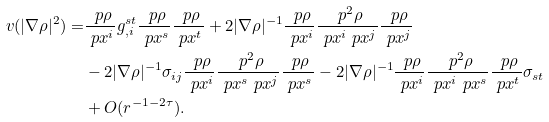<formula> <loc_0><loc_0><loc_500><loc_500>v ( | \nabla \rho | ^ { 2 } ) = & \frac { \ p \rho } { \ p x ^ { i } } g ^ { s t } _ { , i } \frac { \ p \rho } { \ p x ^ { s } } \frac { \ p \rho } { \ p x ^ { t } } + 2 | \nabla \rho | ^ { - 1 } \frac { \ p \rho } { \ p x ^ { i } } \frac { \ p ^ { 2 } \rho } { \ p x ^ { i } \ p x ^ { j } } \frac { \ p \rho } { \ p x ^ { j } } \\ & - 2 | \nabla \rho | ^ { - 1 } \sigma _ { i j } \frac { \ p \rho } { \ p x ^ { i } } \frac { \ p ^ { 2 } \rho } { \ p x ^ { s } \ p x ^ { j } } \frac { \ p \rho } { \ p x ^ { s } } - 2 | \nabla \rho | ^ { - 1 } \frac { \ p \rho } { \ p x ^ { i } } \frac { \ p ^ { 2 } \rho } { \ p x ^ { i } \ p x ^ { s } } \frac { \ p \rho } { \ p x ^ { t } } \sigma _ { s t } \\ & + O ( r ^ { - 1 - 2 \tau } ) .</formula> 